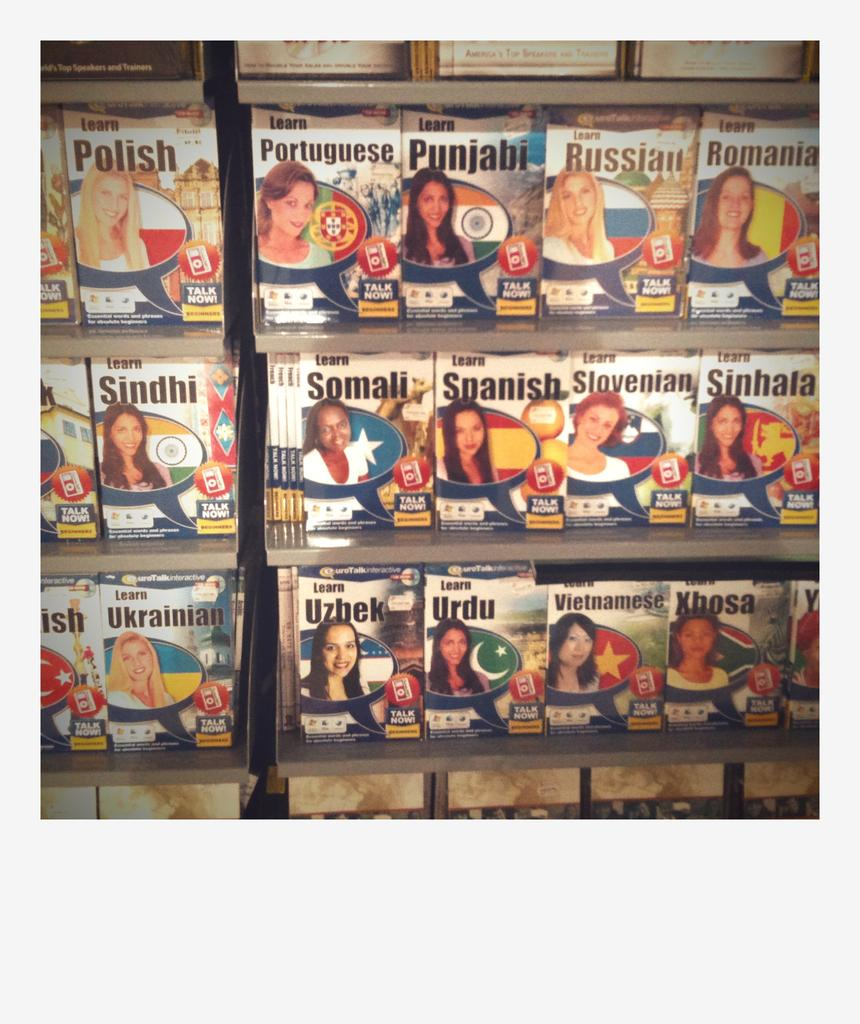<image>
Offer a succinct explanation of the picture presented. A shelf containing books on how to learn languages such as Russian or Spanish. 